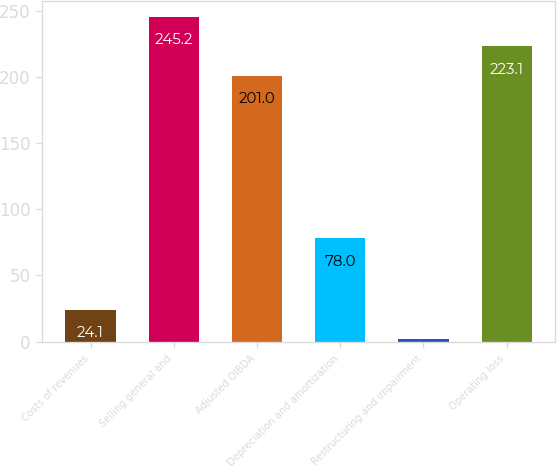Convert chart to OTSL. <chart><loc_0><loc_0><loc_500><loc_500><bar_chart><fcel>Costs of revenues<fcel>Selling general and<fcel>Adjusted OIBDA<fcel>Depreciation and amortization<fcel>Restructuring and impairment<fcel>Operating loss<nl><fcel>24.1<fcel>245.2<fcel>201<fcel>78<fcel>2<fcel>223.1<nl></chart> 